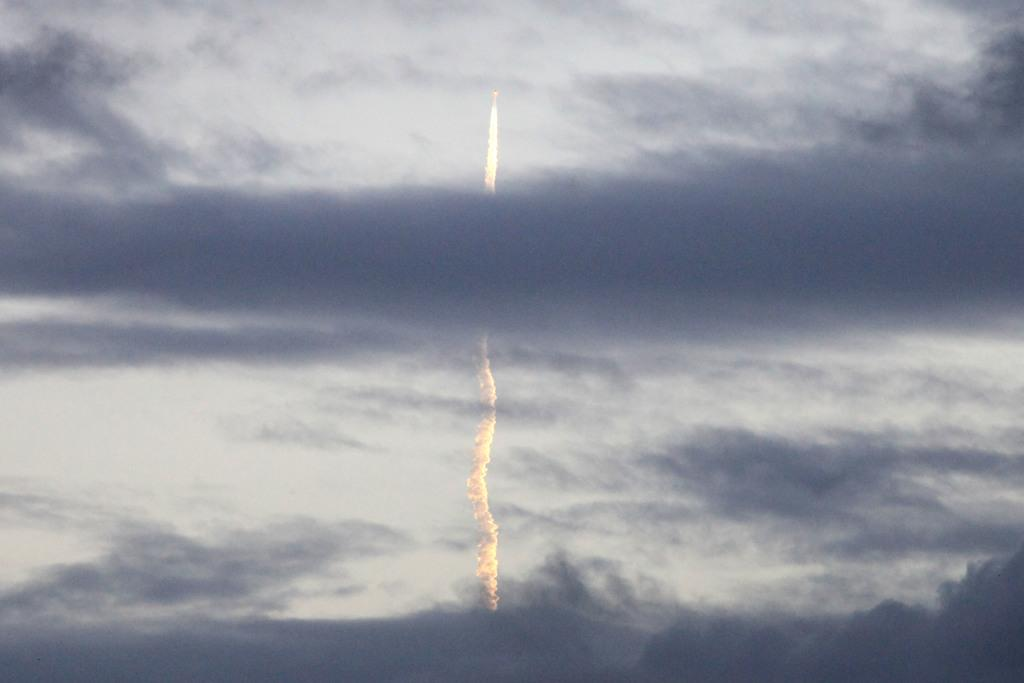What is the main subject of the image? The main subject of the image is a jet. What is the jet doing in the image? The jet is moving in the image. What can be seen below the path of the jet? There is smoke below the path of the jet. What is the condition of the sky in the image? The sky is cloudy in the image. What type of birthday celebration is happening in the image? There is no indication of a birthday celebration in the image; it features a moving jet with smoke below its path. What is the jet using to stop its movement in the image? The jet is not shown stopping its movement in the image, and there is no mention of a brake or any other mechanism for stopping. 